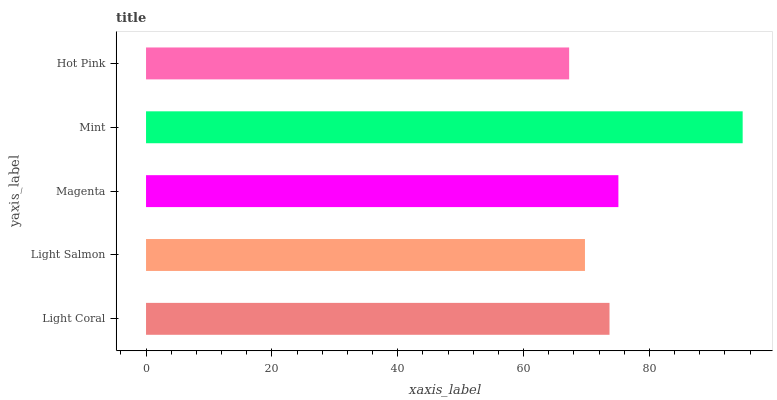Is Hot Pink the minimum?
Answer yes or no. Yes. Is Mint the maximum?
Answer yes or no. Yes. Is Light Salmon the minimum?
Answer yes or no. No. Is Light Salmon the maximum?
Answer yes or no. No. Is Light Coral greater than Light Salmon?
Answer yes or no. Yes. Is Light Salmon less than Light Coral?
Answer yes or no. Yes. Is Light Salmon greater than Light Coral?
Answer yes or no. No. Is Light Coral less than Light Salmon?
Answer yes or no. No. Is Light Coral the high median?
Answer yes or no. Yes. Is Light Coral the low median?
Answer yes or no. Yes. Is Light Salmon the high median?
Answer yes or no. No. Is Mint the low median?
Answer yes or no. No. 